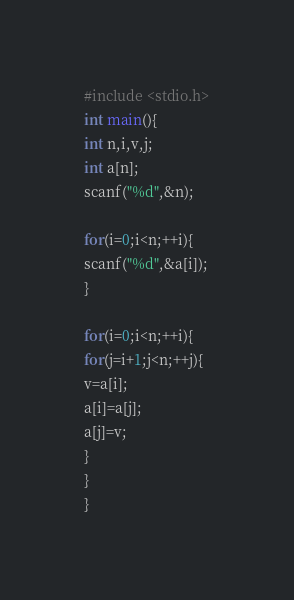<code> <loc_0><loc_0><loc_500><loc_500><_C_>#include <stdio.h>
int main(){
int n,i,v,j;
int a[n];
scanf("%d",&n);

for(i=0;i<n;++i){
scanf("%d",&a[i]);
}

for(i=0;i<n;++i){
for(j=i+1;j<n;++j){
v=a[i];
a[i]=a[j];
a[j]=v;
}
}
}</code> 